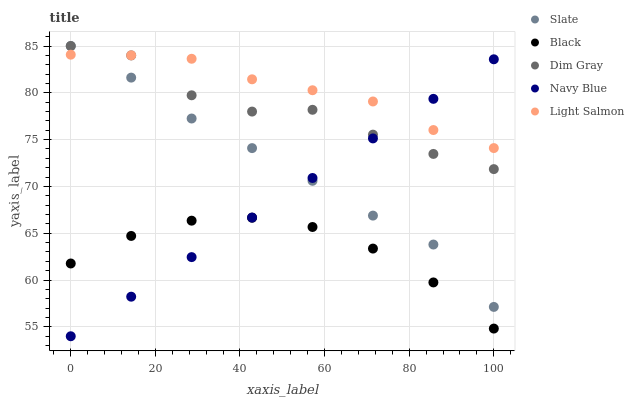Does Black have the minimum area under the curve?
Answer yes or no. Yes. Does Light Salmon have the maximum area under the curve?
Answer yes or no. Yes. Does Slate have the minimum area under the curve?
Answer yes or no. No. Does Slate have the maximum area under the curve?
Answer yes or no. No. Is Navy Blue the smoothest?
Answer yes or no. Yes. Is Dim Gray the roughest?
Answer yes or no. Yes. Is Slate the smoothest?
Answer yes or no. No. Is Slate the roughest?
Answer yes or no. No. Does Navy Blue have the lowest value?
Answer yes or no. Yes. Does Slate have the lowest value?
Answer yes or no. No. Does Dim Gray have the highest value?
Answer yes or no. Yes. Does Black have the highest value?
Answer yes or no. No. Is Black less than Light Salmon?
Answer yes or no. Yes. Is Slate greater than Black?
Answer yes or no. Yes. Does Slate intersect Dim Gray?
Answer yes or no. Yes. Is Slate less than Dim Gray?
Answer yes or no. No. Is Slate greater than Dim Gray?
Answer yes or no. No. Does Black intersect Light Salmon?
Answer yes or no. No. 